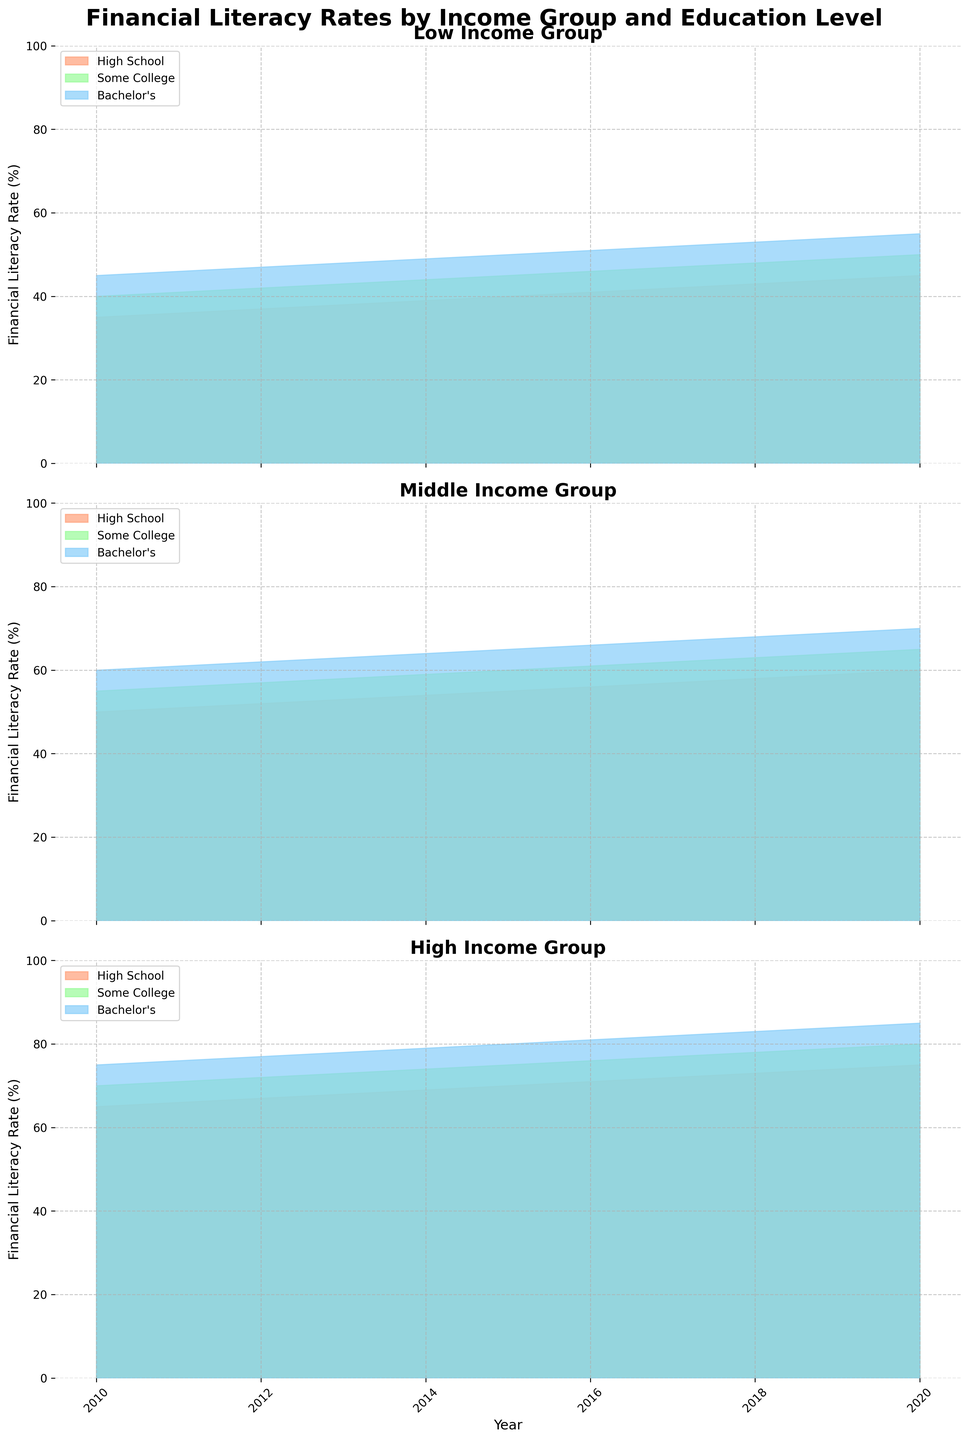What is the title of the figure? The title is usually positioned at the top of the figure and is typically in bold or larger font. Here, we see "Financial Literacy Rates by Income Group and Education Level" as the title.
Answer: Financial Literacy Rates by Income Group and Education Level How many income groups are represented in the figure? The figure is divided into 3 subplots, one for each income group. The titles of these subplots are "Low Income Group," "Middle Income Group," and "High Income Group."
Answer: 3 What colors represent the different education levels? The colors used to fill the areas corresponding to education levels are often distinguishable by visual cues. Here, "High School" is Salmon, "Some College*" is LightGreen, and "Bachelor's" is LightBlue.
Answer: Salmon, LightGreen, LightBlue In which year did the "Low Income - Bachelor's" group have a financial literacy rate of 55%? Locate the "Low Income" subplot and then find the "Bachelor's" area. Check the information on the x-axis to identify the year where the value reaches 55%. It is in 2020.
Answer: 2020 What is the difference in financial literacy rates between "Middle Income - Some College" and "High Income - High School" in 2014? For "Middle Income - Some College," find the corresponding area on the middle subplot in 2014, which is 59%. For "High Income - High School," find the area on the high-income subplot in 2014, which is 69%. The difference is 69% - 59% = 10%.
Answer: 10% Does the financial literacy rate for the "High Income - Bachelor's" group exceed 80% at any point? Look at the "High Income" subplot, focusing on the "Bachelor's" level. Check if the filled area surpasses the 80% line. It does in the year 2020.
Answer: Yes Which income group shows the highest overall growth in financial literacy rates from 2010 to 2020 for the "High School" education level? Look at the starting (2010) and ending (2020) points for the "High School" level in all three income subgroups. "Low Income" moves from 35% to 45% (an increase of 10%), "Middle Income" moves from 50% to 60% (an increase of 10%), and "High Income" moves from 65% to 75% (an increase of 10%).
Answer: All groups have the same growth Which education level shows the largest improvement in financial literacy rates for the "Low Income" group between 2010 and 2020? Examine the "Low Income" subplot and compare the growth for each education level from 2010 to 2020. "High School" went from 35% to 45% (+10%), "Some College" from 40% to 50% (+10%), "Bachelor's" from 45% to 55% (+10%).
Answer: All levels have the same improvement 